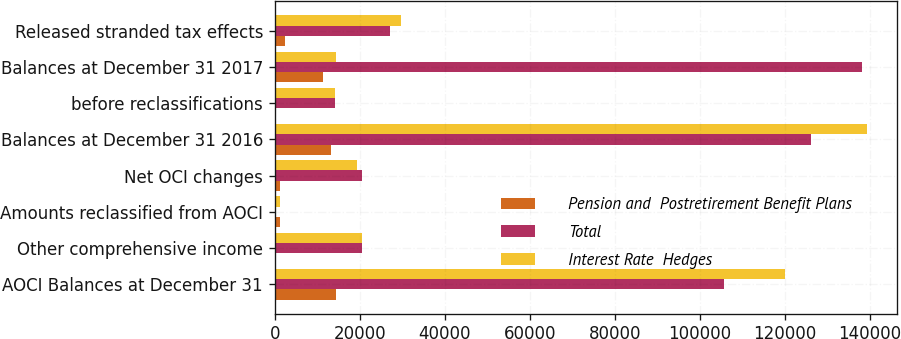Convert chart to OTSL. <chart><loc_0><loc_0><loc_500><loc_500><stacked_bar_chart><ecel><fcel>AOCI Balances at December 31<fcel>Other comprehensive income<fcel>Amounts reclassified from AOCI<fcel>Net OCI changes<fcel>Balances at December 31 2016<fcel>before reclassifications<fcel>Balances at December 31 2017<fcel>Released stranded tax effects<nl><fcel>Pension and  Postretirement Benefit Plans<fcel>14494<fcel>0<fcel>1194<fcel>1194<fcel>13300<fcel>0<fcel>11438<fcel>2464<nl><fcel>Total<fcel>105575<fcel>20583<fcel>82<fcel>20501<fcel>126076<fcel>14106<fcel>138028<fcel>27165<nl><fcel>Interest Rate  Hedges<fcel>120069<fcel>20583<fcel>1276<fcel>19307<fcel>139376<fcel>14106<fcel>14494<fcel>29629<nl></chart> 